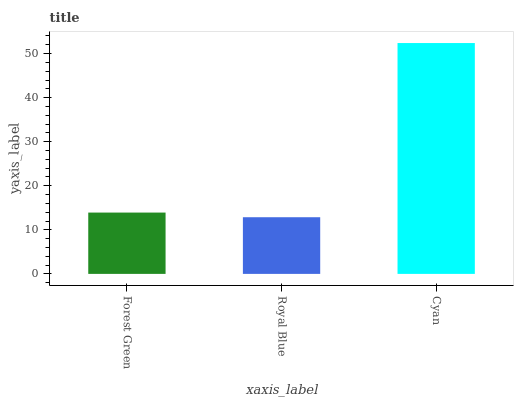Is Royal Blue the minimum?
Answer yes or no. Yes. Is Cyan the maximum?
Answer yes or no. Yes. Is Cyan the minimum?
Answer yes or no. No. Is Royal Blue the maximum?
Answer yes or no. No. Is Cyan greater than Royal Blue?
Answer yes or no. Yes. Is Royal Blue less than Cyan?
Answer yes or no. Yes. Is Royal Blue greater than Cyan?
Answer yes or no. No. Is Cyan less than Royal Blue?
Answer yes or no. No. Is Forest Green the high median?
Answer yes or no. Yes. Is Forest Green the low median?
Answer yes or no. Yes. Is Cyan the high median?
Answer yes or no. No. Is Royal Blue the low median?
Answer yes or no. No. 